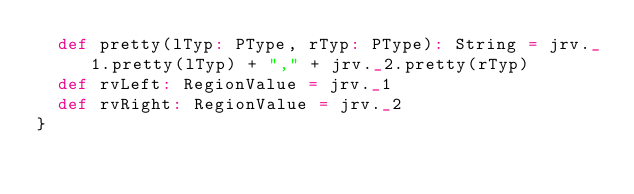<code> <loc_0><loc_0><loc_500><loc_500><_Scala_>  def pretty(lTyp: PType, rTyp: PType): String = jrv._1.pretty(lTyp) + "," + jrv._2.pretty(rTyp)
  def rvLeft: RegionValue = jrv._1
  def rvRight: RegionValue = jrv._2
}
</code> 